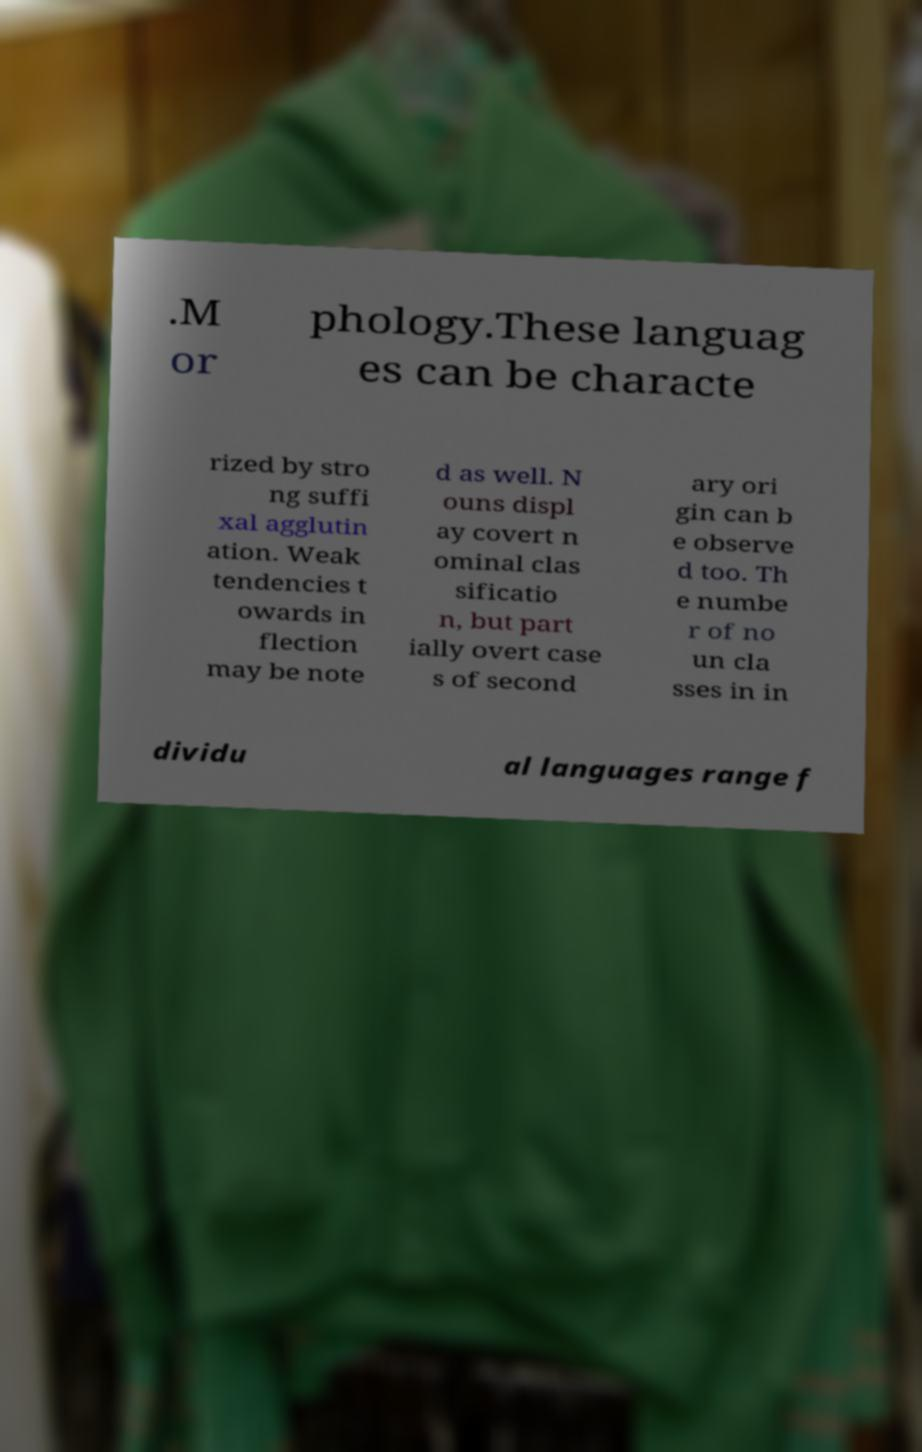For documentation purposes, I need the text within this image transcribed. Could you provide that? .M or phology.These languag es can be characte rized by stro ng suffi xal agglutin ation. Weak tendencies t owards in flection may be note d as well. N ouns displ ay covert n ominal clas sificatio n, but part ially overt case s of second ary ori gin can b e observe d too. Th e numbe r of no un cla sses in in dividu al languages range f 